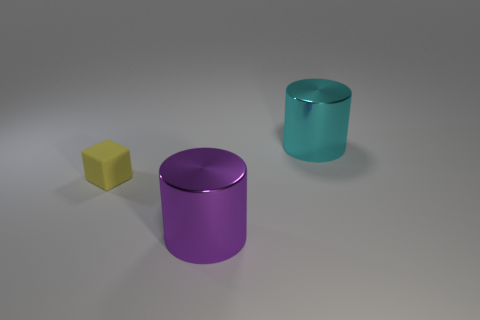Is there anything else that is the same material as the yellow object?
Your answer should be compact. No. Is there a cube that has the same size as the purple thing?
Ensure brevity in your answer.  No. What number of things are both to the left of the large purple cylinder and on the right side of the purple object?
Keep it short and to the point. 0. There is a yellow thing; how many rubber blocks are on the right side of it?
Keep it short and to the point. 0. Is there another shiny thing that has the same shape as the purple metal object?
Keep it short and to the point. Yes. There is a purple metal object; is it the same shape as the big shiny object that is behind the big purple cylinder?
Make the answer very short. Yes. How many balls are large cyan things or small matte things?
Your answer should be compact. 0. There is a big metal thing that is behind the tiny matte thing; what is its shape?
Keep it short and to the point. Cylinder. How many cyan cylinders have the same material as the purple object?
Your answer should be compact. 1. Is the number of yellow matte things to the right of the large purple object less than the number of blocks?
Give a very brief answer. Yes. 